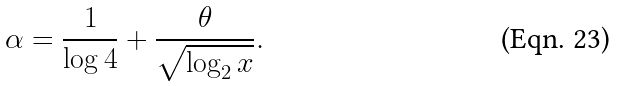<formula> <loc_0><loc_0><loc_500><loc_500>\alpha = \frac { 1 } { \log 4 } + \frac { \theta } { \sqrt { \log _ { 2 } x } } .</formula> 